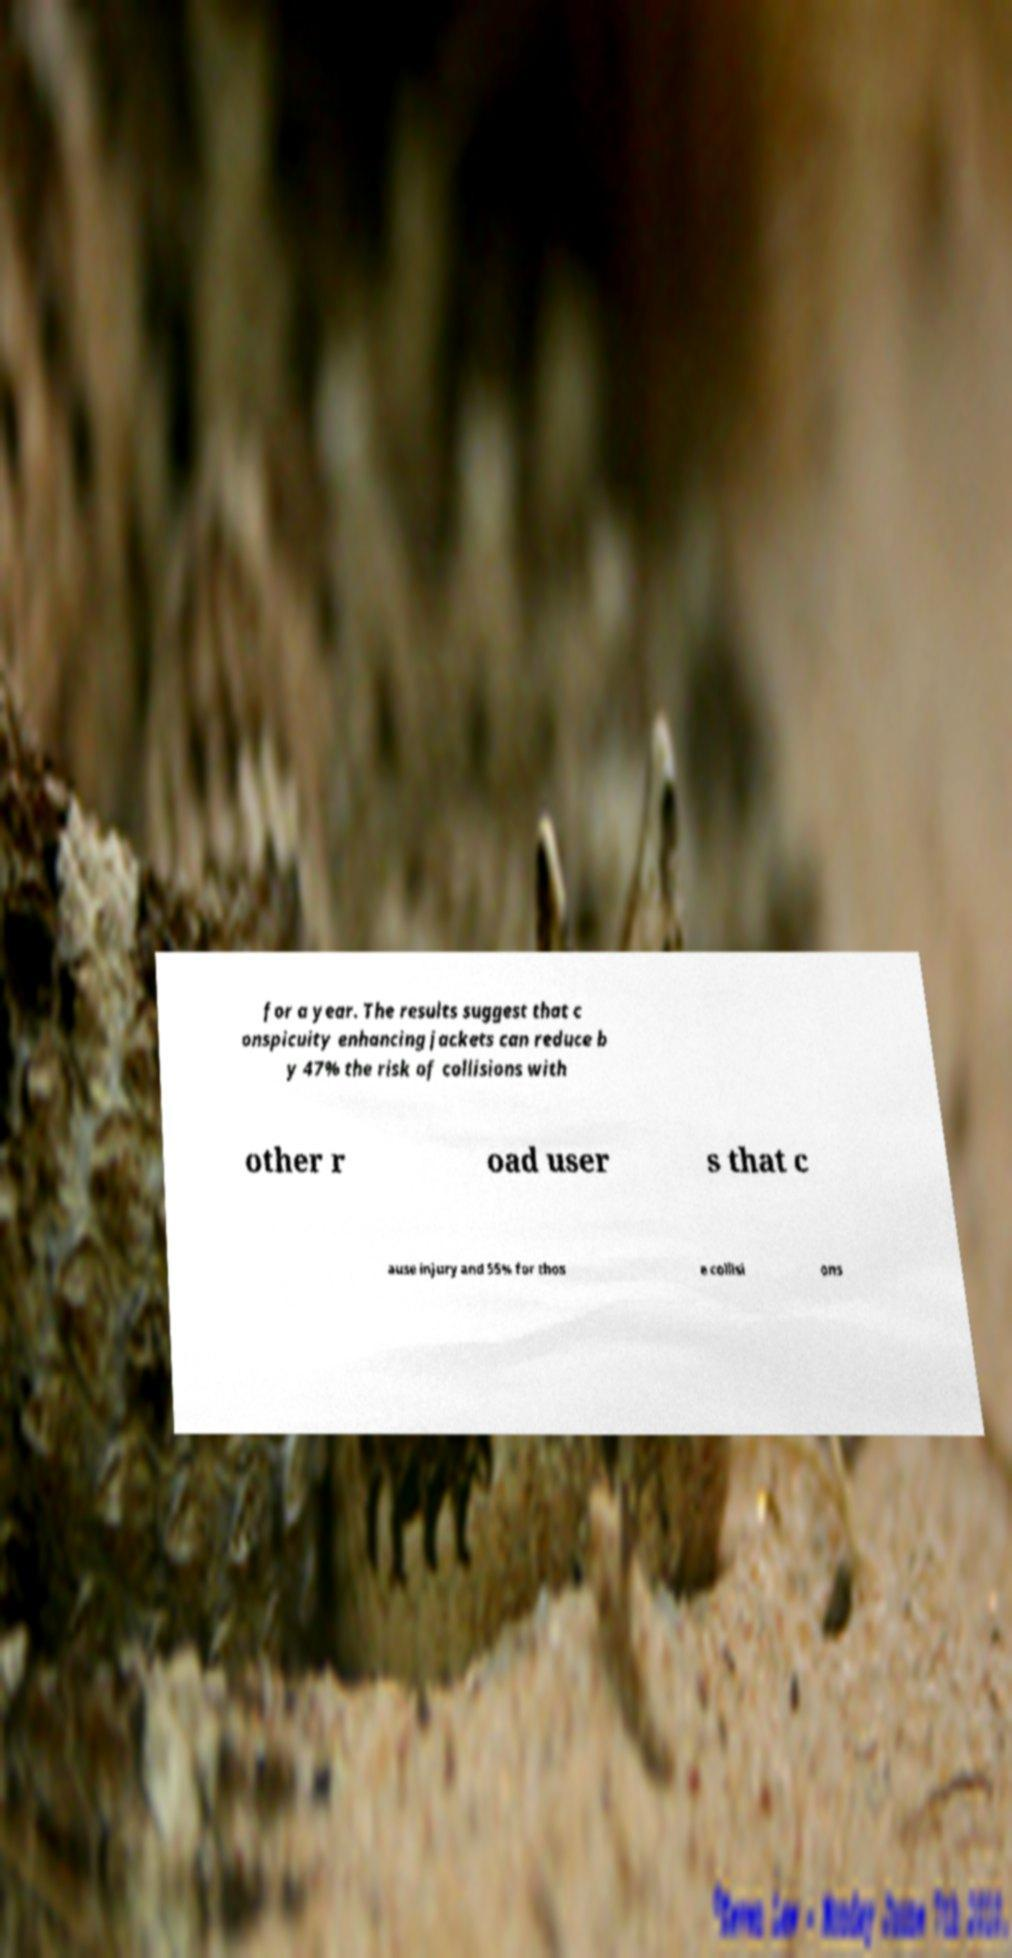Can you read and provide the text displayed in the image?This photo seems to have some interesting text. Can you extract and type it out for me? for a year. The results suggest that c onspicuity enhancing jackets can reduce b y 47% the risk of collisions with other r oad user s that c ause injury and 55% for thos e collisi ons 